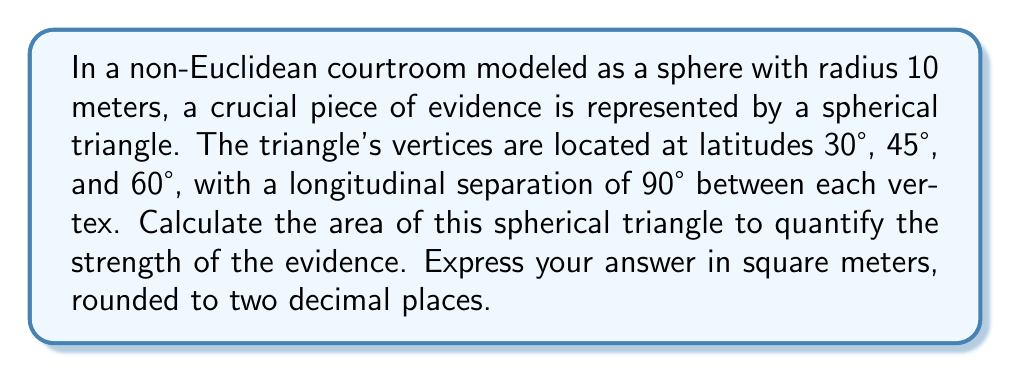Give your solution to this math problem. To solve this problem, we'll use the formula for the area of a spherical triangle on a sphere of radius $R$:

$$A = R^2 (α + β + γ - π)$$

Where $α$, $β$, and $γ$ are the angles of the spherical triangle in radians.

Steps:
1) First, we need to find the angles of the spherical triangle. We can use the spherical law of cosines:

   $$\cos(a) = \sin(b)\sin(c)\cos(A) + \cos(b)\cos(c)$$

   Where $a$, $b$, and $c$ are the side lengths (in radians) and $A$ is the angle opposite side $a$.

2) The side lengths in our triangle are all 90° or $\frac{\pi}{2}$ radians.

3) Plugging into the formula:

   $$\cos(\frac{\pi}{2}) = \sin(\frac{\pi}{2})\sin(\frac{\pi}{2})\cos(A) + \cos(\frac{\pi}{2})\cos(\frac{\pi}{2})$$

4) Simplifying:

   $$0 = 1 \cdot 1 \cdot \cos(A) + 0 \cdot 0$$
   $$0 = \cos(A)$$

5) Solving:

   $$A = \arccos(0) = \frac{\pi}{2}$$

6) Due to the symmetry of the triangle, all angles are $\frac{\pi}{2}$.

7) Now we can use the area formula:

   $$A = R^2 (\frac{\pi}{2} + \frac{\pi}{2} + \frac{\pi}{2} - π)$$
   $$A = R^2 (\frac{3π}{2} - π) = R^2 \cdot \frac{\pi}{2}$$

8) Plugging in $R = 10$:

   $$A = 100 \cdot \frac{\pi}{2} = 50π$$

9) Converting to square meters and rounding to two decimal places:

   $$A ≈ 157.08 \text{ m}^2$$
Answer: 157.08 m² 